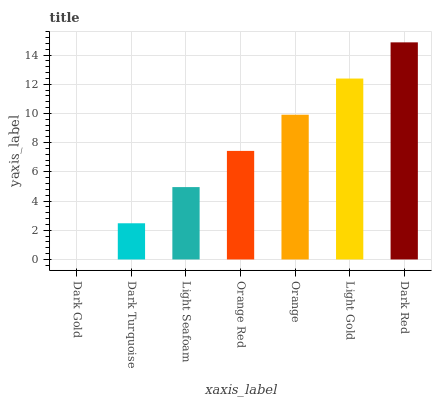Is Dark Gold the minimum?
Answer yes or no. Yes. Is Dark Red the maximum?
Answer yes or no. Yes. Is Dark Turquoise the minimum?
Answer yes or no. No. Is Dark Turquoise the maximum?
Answer yes or no. No. Is Dark Turquoise greater than Dark Gold?
Answer yes or no. Yes. Is Dark Gold less than Dark Turquoise?
Answer yes or no. Yes. Is Dark Gold greater than Dark Turquoise?
Answer yes or no. No. Is Dark Turquoise less than Dark Gold?
Answer yes or no. No. Is Orange Red the high median?
Answer yes or no. Yes. Is Orange Red the low median?
Answer yes or no. Yes. Is Dark Red the high median?
Answer yes or no. No. Is Dark Gold the low median?
Answer yes or no. No. 